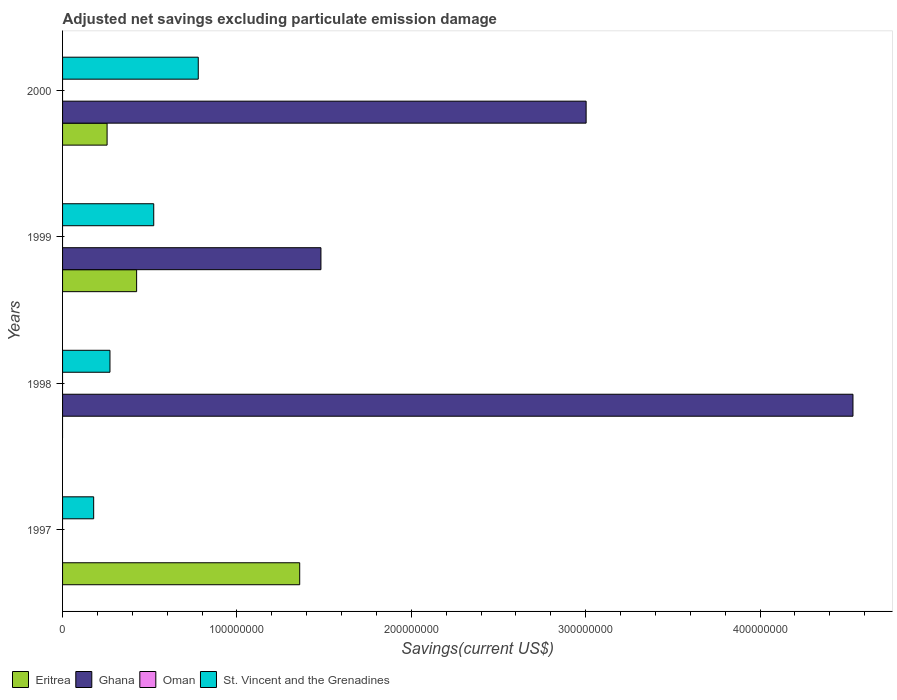How many different coloured bars are there?
Provide a succinct answer. 3. How many groups of bars are there?
Keep it short and to the point. 4. Are the number of bars per tick equal to the number of legend labels?
Ensure brevity in your answer.  No. What is the label of the 3rd group of bars from the top?
Offer a very short reply. 1998. What is the adjusted net savings in Oman in 1997?
Give a very brief answer. 0. Across all years, what is the maximum adjusted net savings in St. Vincent and the Grenadines?
Ensure brevity in your answer.  7.78e+07. What is the total adjusted net savings in Oman in the graph?
Give a very brief answer. 0. What is the difference between the adjusted net savings in St. Vincent and the Grenadines in 1997 and that in 2000?
Provide a short and direct response. -6.00e+07. What is the difference between the adjusted net savings in Ghana in 1997 and the adjusted net savings in St. Vincent and the Grenadines in 1999?
Offer a very short reply. -5.23e+07. What is the average adjusted net savings in Oman per year?
Provide a succinct answer. 0. In the year 1999, what is the difference between the adjusted net savings in Ghana and adjusted net savings in St. Vincent and the Grenadines?
Make the answer very short. 9.59e+07. What is the ratio of the adjusted net savings in Ghana in 1999 to that in 2000?
Offer a terse response. 0.49. Is the difference between the adjusted net savings in Ghana in 1999 and 2000 greater than the difference between the adjusted net savings in St. Vincent and the Grenadines in 1999 and 2000?
Keep it short and to the point. No. What is the difference between the highest and the second highest adjusted net savings in Eritrea?
Your answer should be compact. 9.35e+07. What is the difference between the highest and the lowest adjusted net savings in Ghana?
Offer a terse response. 4.53e+08. Is the sum of the adjusted net savings in St. Vincent and the Grenadines in 1997 and 1998 greater than the maximum adjusted net savings in Oman across all years?
Your response must be concise. Yes. Is it the case that in every year, the sum of the adjusted net savings in St. Vincent and the Grenadines and adjusted net savings in Eritrea is greater than the adjusted net savings in Oman?
Make the answer very short. Yes. How many bars are there?
Ensure brevity in your answer.  10. Are all the bars in the graph horizontal?
Provide a short and direct response. Yes. What is the difference between two consecutive major ticks on the X-axis?
Your answer should be compact. 1.00e+08. Are the values on the major ticks of X-axis written in scientific E-notation?
Offer a very short reply. No. How many legend labels are there?
Provide a short and direct response. 4. How are the legend labels stacked?
Provide a succinct answer. Horizontal. What is the title of the graph?
Ensure brevity in your answer.  Adjusted net savings excluding particulate emission damage. Does "Austria" appear as one of the legend labels in the graph?
Provide a succinct answer. No. What is the label or title of the X-axis?
Your answer should be compact. Savings(current US$). What is the Savings(current US$) of Eritrea in 1997?
Your answer should be compact. 1.36e+08. What is the Savings(current US$) of St. Vincent and the Grenadines in 1997?
Offer a very short reply. 1.78e+07. What is the Savings(current US$) in Ghana in 1998?
Keep it short and to the point. 4.53e+08. What is the Savings(current US$) in Oman in 1998?
Make the answer very short. 0. What is the Savings(current US$) in St. Vincent and the Grenadines in 1998?
Offer a very short reply. 2.72e+07. What is the Savings(current US$) in Eritrea in 1999?
Offer a very short reply. 4.25e+07. What is the Savings(current US$) in Ghana in 1999?
Offer a very short reply. 1.48e+08. What is the Savings(current US$) of Oman in 1999?
Make the answer very short. 0. What is the Savings(current US$) of St. Vincent and the Grenadines in 1999?
Keep it short and to the point. 5.23e+07. What is the Savings(current US$) of Eritrea in 2000?
Provide a succinct answer. 2.55e+07. What is the Savings(current US$) in Ghana in 2000?
Make the answer very short. 3.00e+08. What is the Savings(current US$) in Oman in 2000?
Give a very brief answer. 0. What is the Savings(current US$) of St. Vincent and the Grenadines in 2000?
Your answer should be very brief. 7.78e+07. Across all years, what is the maximum Savings(current US$) of Eritrea?
Provide a short and direct response. 1.36e+08. Across all years, what is the maximum Savings(current US$) of Ghana?
Offer a terse response. 4.53e+08. Across all years, what is the maximum Savings(current US$) in St. Vincent and the Grenadines?
Your answer should be compact. 7.78e+07. Across all years, what is the minimum Savings(current US$) in Ghana?
Offer a very short reply. 0. Across all years, what is the minimum Savings(current US$) in St. Vincent and the Grenadines?
Your answer should be compact. 1.78e+07. What is the total Savings(current US$) of Eritrea in the graph?
Provide a short and direct response. 2.04e+08. What is the total Savings(current US$) in Ghana in the graph?
Provide a short and direct response. 9.02e+08. What is the total Savings(current US$) of St. Vincent and the Grenadines in the graph?
Make the answer very short. 1.75e+08. What is the difference between the Savings(current US$) of St. Vincent and the Grenadines in 1997 and that in 1998?
Provide a succinct answer. -9.35e+06. What is the difference between the Savings(current US$) in Eritrea in 1997 and that in 1999?
Your answer should be compact. 9.35e+07. What is the difference between the Savings(current US$) of St. Vincent and the Grenadines in 1997 and that in 1999?
Offer a terse response. -3.44e+07. What is the difference between the Savings(current US$) in Eritrea in 1997 and that in 2000?
Offer a very short reply. 1.10e+08. What is the difference between the Savings(current US$) in St. Vincent and the Grenadines in 1997 and that in 2000?
Provide a short and direct response. -6.00e+07. What is the difference between the Savings(current US$) of Ghana in 1998 and that in 1999?
Your answer should be compact. 3.05e+08. What is the difference between the Savings(current US$) in St. Vincent and the Grenadines in 1998 and that in 1999?
Offer a very short reply. -2.51e+07. What is the difference between the Savings(current US$) of Ghana in 1998 and that in 2000?
Your response must be concise. 1.53e+08. What is the difference between the Savings(current US$) in St. Vincent and the Grenadines in 1998 and that in 2000?
Your answer should be compact. -5.06e+07. What is the difference between the Savings(current US$) of Eritrea in 1999 and that in 2000?
Ensure brevity in your answer.  1.69e+07. What is the difference between the Savings(current US$) in Ghana in 1999 and that in 2000?
Ensure brevity in your answer.  -1.52e+08. What is the difference between the Savings(current US$) in St. Vincent and the Grenadines in 1999 and that in 2000?
Provide a succinct answer. -2.55e+07. What is the difference between the Savings(current US$) in Eritrea in 1997 and the Savings(current US$) in Ghana in 1998?
Your answer should be compact. -3.17e+08. What is the difference between the Savings(current US$) of Eritrea in 1997 and the Savings(current US$) of St. Vincent and the Grenadines in 1998?
Keep it short and to the point. 1.09e+08. What is the difference between the Savings(current US$) of Eritrea in 1997 and the Savings(current US$) of Ghana in 1999?
Your response must be concise. -1.22e+07. What is the difference between the Savings(current US$) in Eritrea in 1997 and the Savings(current US$) in St. Vincent and the Grenadines in 1999?
Provide a succinct answer. 8.37e+07. What is the difference between the Savings(current US$) in Eritrea in 1997 and the Savings(current US$) in Ghana in 2000?
Give a very brief answer. -1.64e+08. What is the difference between the Savings(current US$) in Eritrea in 1997 and the Savings(current US$) in St. Vincent and the Grenadines in 2000?
Offer a very short reply. 5.82e+07. What is the difference between the Savings(current US$) of Ghana in 1998 and the Savings(current US$) of St. Vincent and the Grenadines in 1999?
Offer a terse response. 4.01e+08. What is the difference between the Savings(current US$) of Ghana in 1998 and the Savings(current US$) of St. Vincent and the Grenadines in 2000?
Ensure brevity in your answer.  3.75e+08. What is the difference between the Savings(current US$) of Eritrea in 1999 and the Savings(current US$) of Ghana in 2000?
Your answer should be very brief. -2.58e+08. What is the difference between the Savings(current US$) in Eritrea in 1999 and the Savings(current US$) in St. Vincent and the Grenadines in 2000?
Your answer should be compact. -3.53e+07. What is the difference between the Savings(current US$) in Ghana in 1999 and the Savings(current US$) in St. Vincent and the Grenadines in 2000?
Provide a short and direct response. 7.04e+07. What is the average Savings(current US$) in Eritrea per year?
Your answer should be compact. 5.10e+07. What is the average Savings(current US$) in Ghana per year?
Ensure brevity in your answer.  2.25e+08. What is the average Savings(current US$) of Oman per year?
Keep it short and to the point. 0. What is the average Savings(current US$) of St. Vincent and the Grenadines per year?
Your answer should be compact. 4.38e+07. In the year 1997, what is the difference between the Savings(current US$) in Eritrea and Savings(current US$) in St. Vincent and the Grenadines?
Offer a terse response. 1.18e+08. In the year 1998, what is the difference between the Savings(current US$) in Ghana and Savings(current US$) in St. Vincent and the Grenadines?
Provide a short and direct response. 4.26e+08. In the year 1999, what is the difference between the Savings(current US$) of Eritrea and Savings(current US$) of Ghana?
Make the answer very short. -1.06e+08. In the year 1999, what is the difference between the Savings(current US$) of Eritrea and Savings(current US$) of St. Vincent and the Grenadines?
Your response must be concise. -9.81e+06. In the year 1999, what is the difference between the Savings(current US$) in Ghana and Savings(current US$) in St. Vincent and the Grenadines?
Make the answer very short. 9.59e+07. In the year 2000, what is the difference between the Savings(current US$) in Eritrea and Savings(current US$) in Ghana?
Provide a short and direct response. -2.75e+08. In the year 2000, what is the difference between the Savings(current US$) in Eritrea and Savings(current US$) in St. Vincent and the Grenadines?
Ensure brevity in your answer.  -5.23e+07. In the year 2000, what is the difference between the Savings(current US$) of Ghana and Savings(current US$) of St. Vincent and the Grenadines?
Provide a short and direct response. 2.22e+08. What is the ratio of the Savings(current US$) in St. Vincent and the Grenadines in 1997 to that in 1998?
Give a very brief answer. 0.66. What is the ratio of the Savings(current US$) of Eritrea in 1997 to that in 1999?
Ensure brevity in your answer.  3.2. What is the ratio of the Savings(current US$) in St. Vincent and the Grenadines in 1997 to that in 1999?
Your response must be concise. 0.34. What is the ratio of the Savings(current US$) of Eritrea in 1997 to that in 2000?
Offer a terse response. 5.33. What is the ratio of the Savings(current US$) in St. Vincent and the Grenadines in 1997 to that in 2000?
Your answer should be very brief. 0.23. What is the ratio of the Savings(current US$) of Ghana in 1998 to that in 1999?
Provide a short and direct response. 3.06. What is the ratio of the Savings(current US$) of St. Vincent and the Grenadines in 1998 to that in 1999?
Give a very brief answer. 0.52. What is the ratio of the Savings(current US$) of Ghana in 1998 to that in 2000?
Make the answer very short. 1.51. What is the ratio of the Savings(current US$) of St. Vincent and the Grenadines in 1998 to that in 2000?
Keep it short and to the point. 0.35. What is the ratio of the Savings(current US$) of Eritrea in 1999 to that in 2000?
Your answer should be very brief. 1.66. What is the ratio of the Savings(current US$) in Ghana in 1999 to that in 2000?
Give a very brief answer. 0.49. What is the ratio of the Savings(current US$) of St. Vincent and the Grenadines in 1999 to that in 2000?
Offer a terse response. 0.67. What is the difference between the highest and the second highest Savings(current US$) in Eritrea?
Your answer should be compact. 9.35e+07. What is the difference between the highest and the second highest Savings(current US$) in Ghana?
Offer a terse response. 1.53e+08. What is the difference between the highest and the second highest Savings(current US$) in St. Vincent and the Grenadines?
Keep it short and to the point. 2.55e+07. What is the difference between the highest and the lowest Savings(current US$) in Eritrea?
Ensure brevity in your answer.  1.36e+08. What is the difference between the highest and the lowest Savings(current US$) in Ghana?
Your answer should be compact. 4.53e+08. What is the difference between the highest and the lowest Savings(current US$) in St. Vincent and the Grenadines?
Your answer should be very brief. 6.00e+07. 